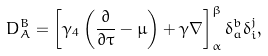<formula> <loc_0><loc_0><loc_500><loc_500>D _ { A } ^ { B } = \left [ \gamma _ { 4 } \left ( \frac { \partial } { \partial \tau } - \mu \right ) + \gamma \nabla \right ] _ { \alpha } ^ { \beta } \delta _ { a } ^ { b } \delta _ { i } ^ { j } ,</formula> 